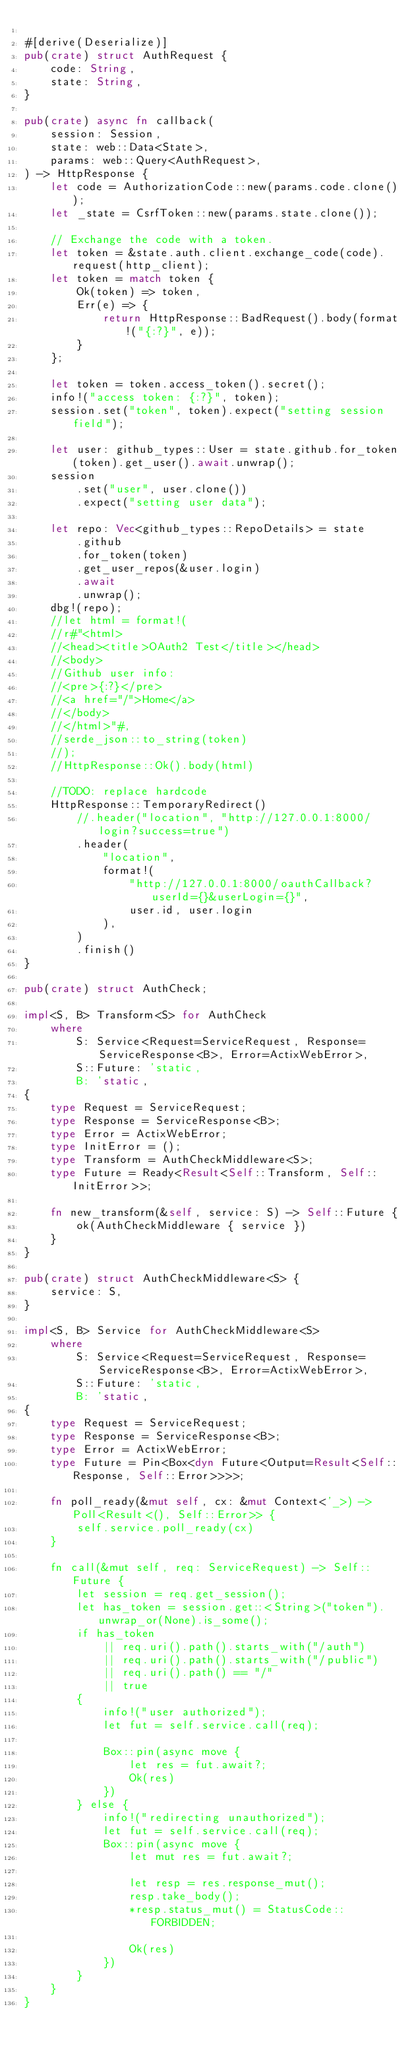<code> <loc_0><loc_0><loc_500><loc_500><_Rust_>
#[derive(Deserialize)]
pub(crate) struct AuthRequest {
    code: String,
    state: String,
}

pub(crate) async fn callback(
    session: Session,
    state: web::Data<State>,
    params: web::Query<AuthRequest>,
) -> HttpResponse {
    let code = AuthorizationCode::new(params.code.clone());
    let _state = CsrfToken::new(params.state.clone());

    // Exchange the code with a token.
    let token = &state.auth.client.exchange_code(code).request(http_client);
    let token = match token {
        Ok(token) => token,
        Err(e) => {
            return HttpResponse::BadRequest().body(format!("{:?}", e));
        }
    };

    let token = token.access_token().secret();
    info!("access token: {:?}", token);
    session.set("token", token).expect("setting session field");

    let user: github_types::User = state.github.for_token(token).get_user().await.unwrap();
    session
        .set("user", user.clone())
        .expect("setting user data");

    let repo: Vec<github_types::RepoDetails> = state
        .github
        .for_token(token)
        .get_user_repos(&user.login)
        .await
        .unwrap();
    dbg!(repo);
    //let html = format!(
    //r#"<html>
    //<head><title>OAuth2 Test</title></head>
    //<body>
    //Github user info:
    //<pre>{:?}</pre>
    //<a href="/">Home</a>
    //</body>
    //</html>"#,
    //serde_json::to_string(token)
    //);
    //HttpResponse::Ok().body(html)

    //TODO: replace hardcode
    HttpResponse::TemporaryRedirect()
        //.header("location", "http://127.0.0.1:8000/login?success=true")
        .header(
            "location",
            format!(
                "http://127.0.0.1:8000/oauthCallback?userId={}&userLogin={}",
                user.id, user.login
            ),
        )
        .finish()
}

pub(crate) struct AuthCheck;

impl<S, B> Transform<S> for AuthCheck
    where
        S: Service<Request=ServiceRequest, Response=ServiceResponse<B>, Error=ActixWebError>,
        S::Future: 'static,
        B: 'static,
{
    type Request = ServiceRequest;
    type Response = ServiceResponse<B>;
    type Error = ActixWebError;
    type InitError = ();
    type Transform = AuthCheckMiddleware<S>;
    type Future = Ready<Result<Self::Transform, Self::InitError>>;

    fn new_transform(&self, service: S) -> Self::Future {
        ok(AuthCheckMiddleware { service })
    }
}

pub(crate) struct AuthCheckMiddleware<S> {
    service: S,
}

impl<S, B> Service for AuthCheckMiddleware<S>
    where
        S: Service<Request=ServiceRequest, Response=ServiceResponse<B>, Error=ActixWebError>,
        S::Future: 'static,
        B: 'static,
{
    type Request = ServiceRequest;
    type Response = ServiceResponse<B>;
    type Error = ActixWebError;
    type Future = Pin<Box<dyn Future<Output=Result<Self::Response, Self::Error>>>>;

    fn poll_ready(&mut self, cx: &mut Context<'_>) -> Poll<Result<(), Self::Error>> {
        self.service.poll_ready(cx)
    }

    fn call(&mut self, req: ServiceRequest) -> Self::Future {
        let session = req.get_session();
        let has_token = session.get::<String>("token").unwrap_or(None).is_some();
        if has_token
            || req.uri().path().starts_with("/auth")
            || req.uri().path().starts_with("/public")
            || req.uri().path() == "/"
            || true
        {
            info!("user authorized");
            let fut = self.service.call(req);

            Box::pin(async move {
                let res = fut.await?;
                Ok(res)
            })
        } else {
            info!("redirecting unauthorized");
            let fut = self.service.call(req);
            Box::pin(async move {
                let mut res = fut.await?;

                let resp = res.response_mut();
                resp.take_body();
                *resp.status_mut() = StatusCode::FORBIDDEN;

                Ok(res)
            })
        }
    }
}
</code> 